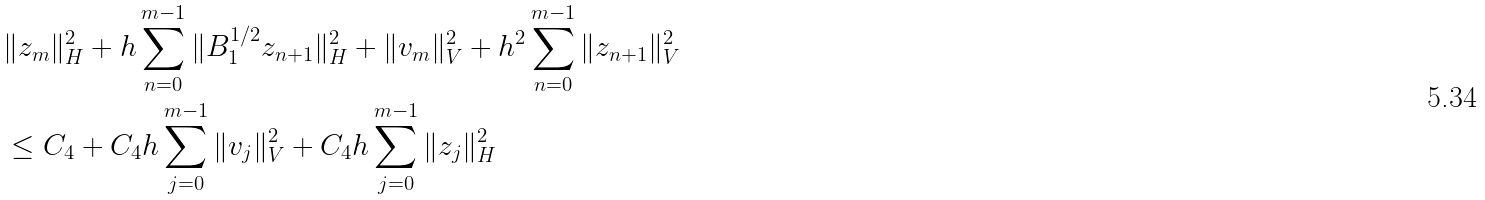<formula> <loc_0><loc_0><loc_500><loc_500>& \| z _ { m } \| _ { H } ^ { 2 } + h \sum _ { n = 0 } ^ { m - 1 } \| B _ { 1 } ^ { 1 / 2 } z _ { n + 1 } \| _ { H } ^ { 2 } + \| v _ { m } \| _ { V } ^ { 2 } + h ^ { 2 } \sum _ { n = 0 } ^ { m - 1 } \| z _ { n + 1 } \| _ { V } ^ { 2 } \\ & \leq C _ { 4 } + C _ { 4 } h \sum _ { j = 0 } ^ { m - 1 } \| v _ { j } \| _ { V } ^ { 2 } + C _ { 4 } h \sum _ { j = 0 } ^ { m - 1 } \| z _ { j } \| _ { H } ^ { 2 }</formula> 